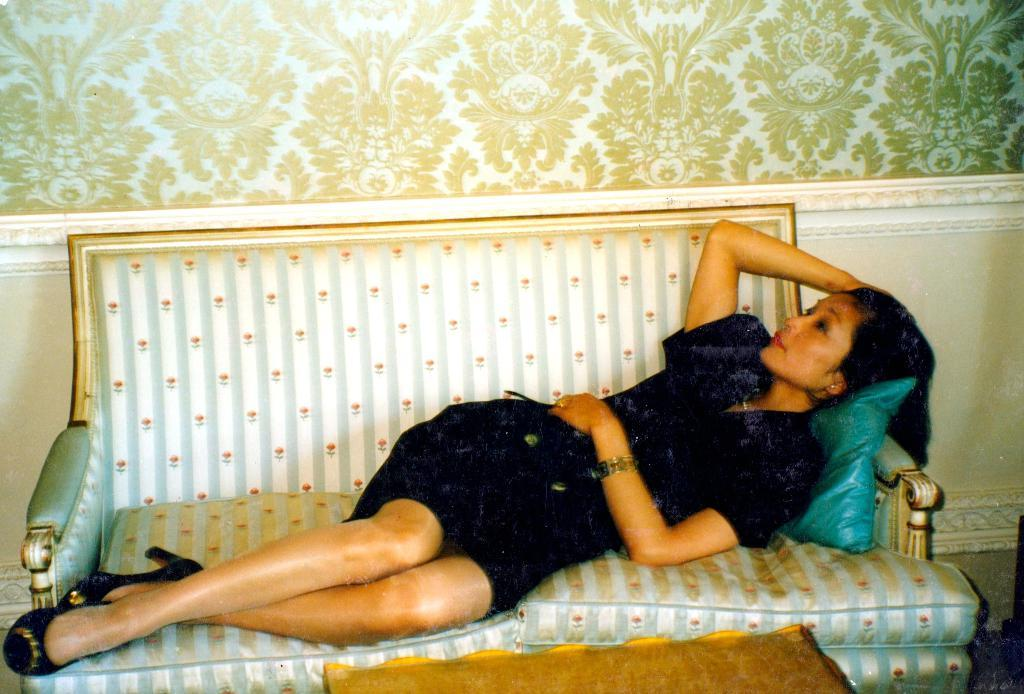Who is the main subject in the image? There is a woman in the image. What is the woman doing in the image? The woman is laying on a sofa. What is the woman wearing in the image? The woman is wearing a black dress. What can be seen in the background of the image? There is a wall in the background of the image. What type of arithmetic problem is the woman solving on the sofa? There is no indication in the image that the woman is solving an arithmetic problem, as she is simply laying on the sofa. 